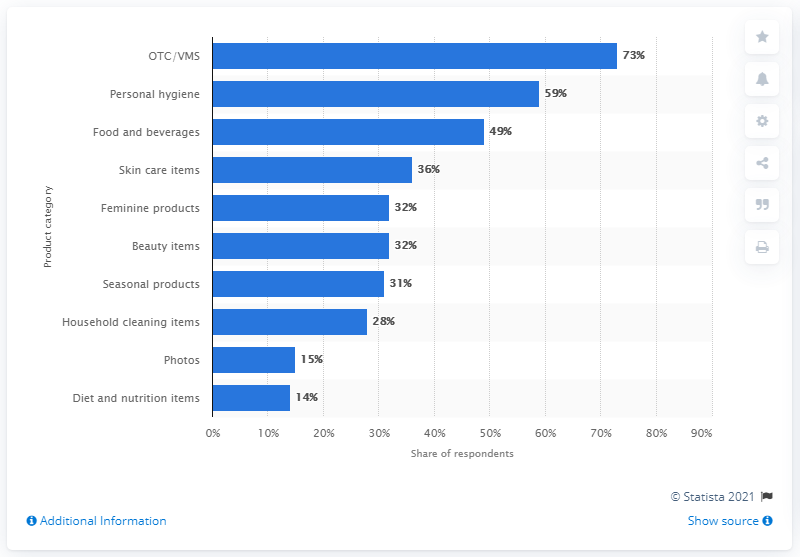Point out several critical features in this image. In 2014, the top product category for consumers was over-the-counter (OTC) and veterinary medical supplies (VMS). 